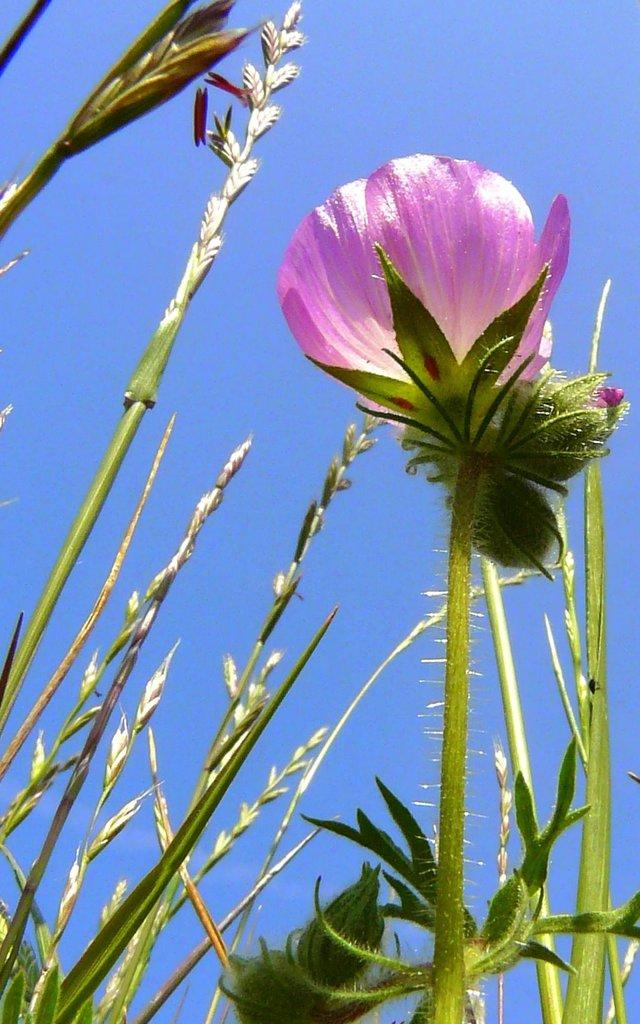What type of plant is in the image? There is a flower with a stem and leaves in the image. Are there any other plants visible in the image? Yes, there are plants in the image. What can be seen in the background of the image? The sky is visible in the background of the image. What type of protest is happening in the image? There is no protest present in the image; it features a flower and plants with the sky visible in the background. Can you tell me how the farmer is interacting with the flower in the image? There is no farmer present in the image; it only shows a flower and plants with the sky visible in the background. 